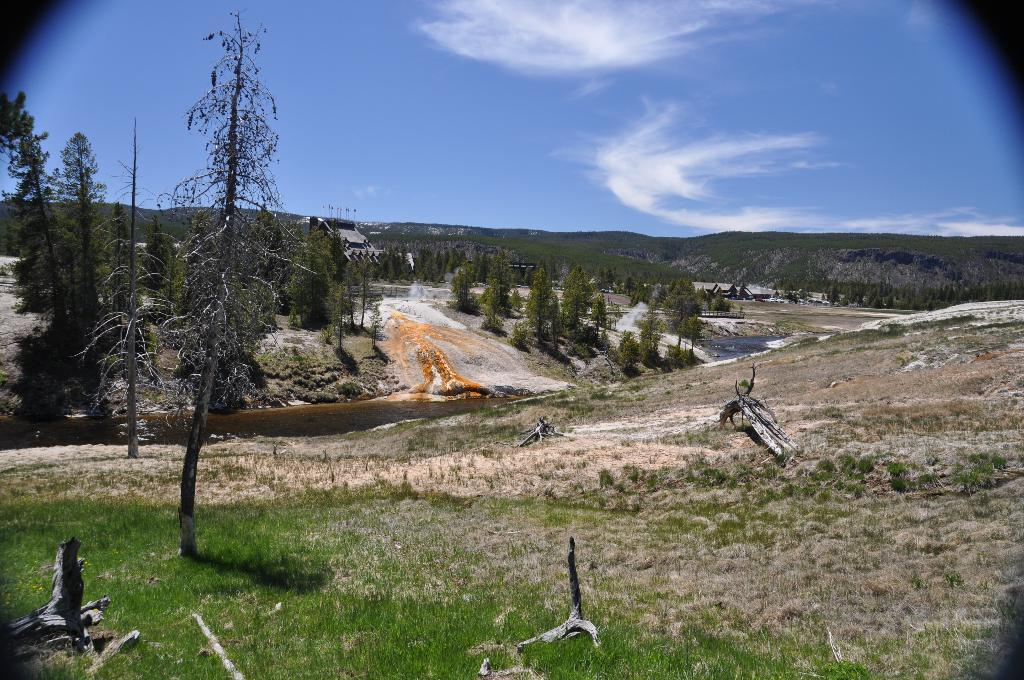What type of vegetation can be seen in the image? There are trees and grass in the image. What natural features are visible in the background of the image? There are mountains in the background of the image. What is visible in the sky in the image? The sky is clear and visible in the background of the image. Can you hear the voice of the kite flying in the image? There is no kite present in the image, and therefore no voice to hear. 